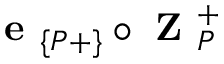<formula> <loc_0><loc_0><loc_500><loc_500>e _ { \{ P + \} } \circ Z _ { P } ^ { + }</formula> 